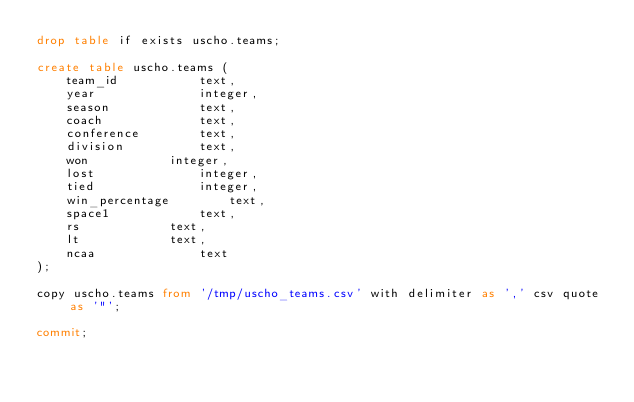Convert code to text. <code><loc_0><loc_0><loc_500><loc_500><_SQL_>drop table if exists uscho.teams;

create table uscho.teams (
	team_id		      text,
	year		      integer,
	season		      text,
	coach		      text,
	conference	      text,
	division	      text,
	won		      integer,
	lost		      integer,
	tied		      integer,
	win_percentage	      text,
	space1		      text,
	rs		      text,
	lt		      text,
	ncaa		      text
);

copy uscho.teams from '/tmp/uscho_teams.csv' with delimiter as ',' csv quote as '"';

commit;
</code> 